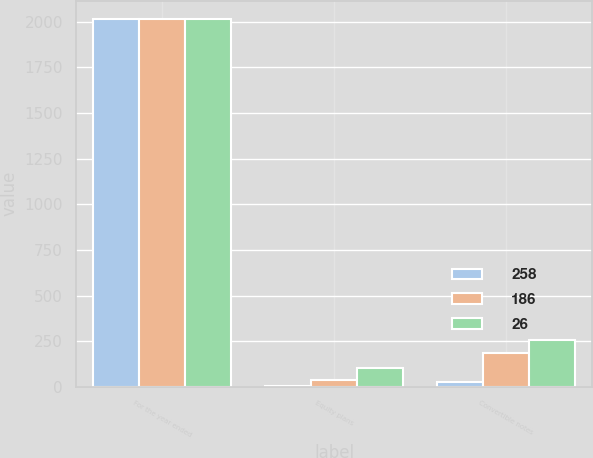Convert chart to OTSL. <chart><loc_0><loc_0><loc_500><loc_500><stacked_bar_chart><ecel><fcel>For the year ended<fcel>Equity plans<fcel>Convertible notes<nl><fcel>258<fcel>2014<fcel>7<fcel>26<nl><fcel>186<fcel>2013<fcel>40<fcel>186<nl><fcel>26<fcel>2012<fcel>105<fcel>258<nl></chart> 